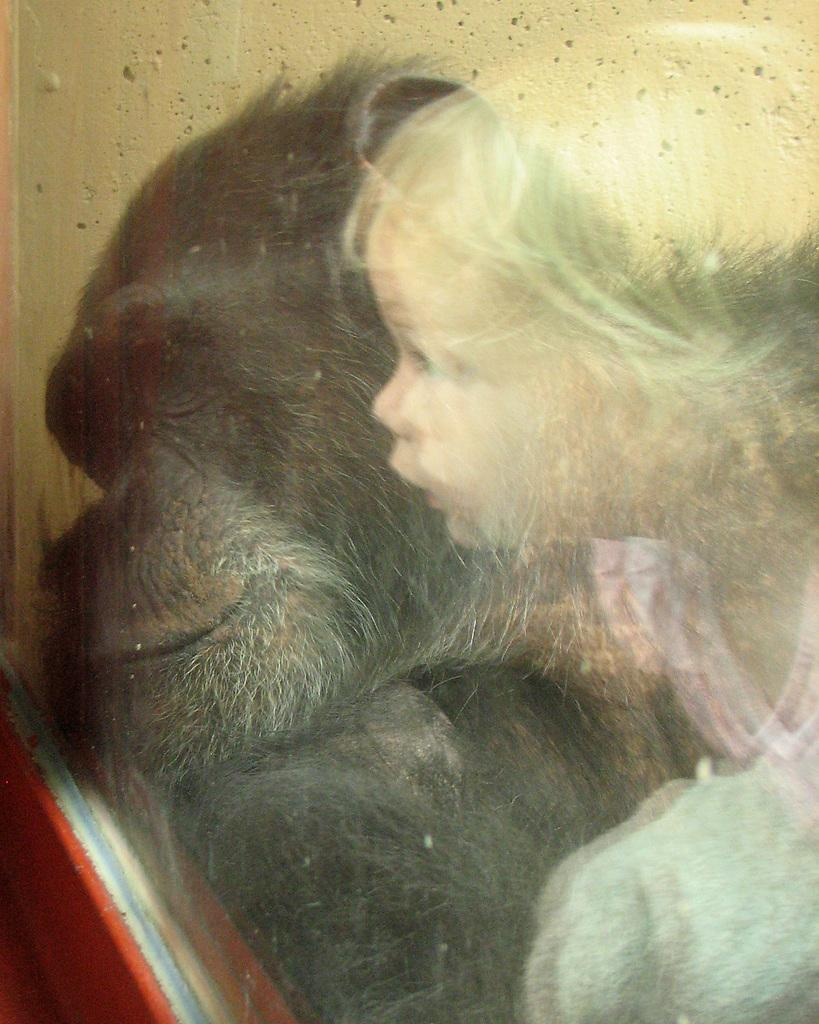What is the main subject of the image? There is a painting in the image. What is depicted in the painting? The painting contains an image of a baby and an animal. What type of wine is being served in the painting? There is no wine present in the painting; it contains an image of a baby and an animal. How many eyes does the baby have in the painting? The number of eyes the baby has cannot be determined from the image, as it is a painting and not a photograph. 